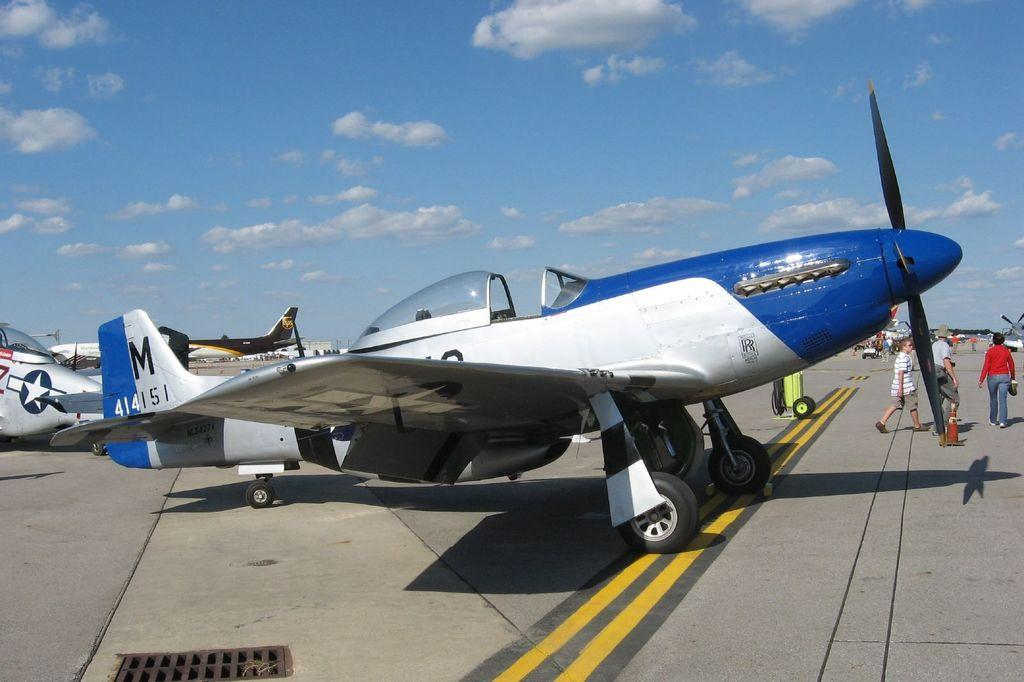Provide a one-sentence caption for the provided image. A blue and white airplane has the numbers 414151 on the tail. 